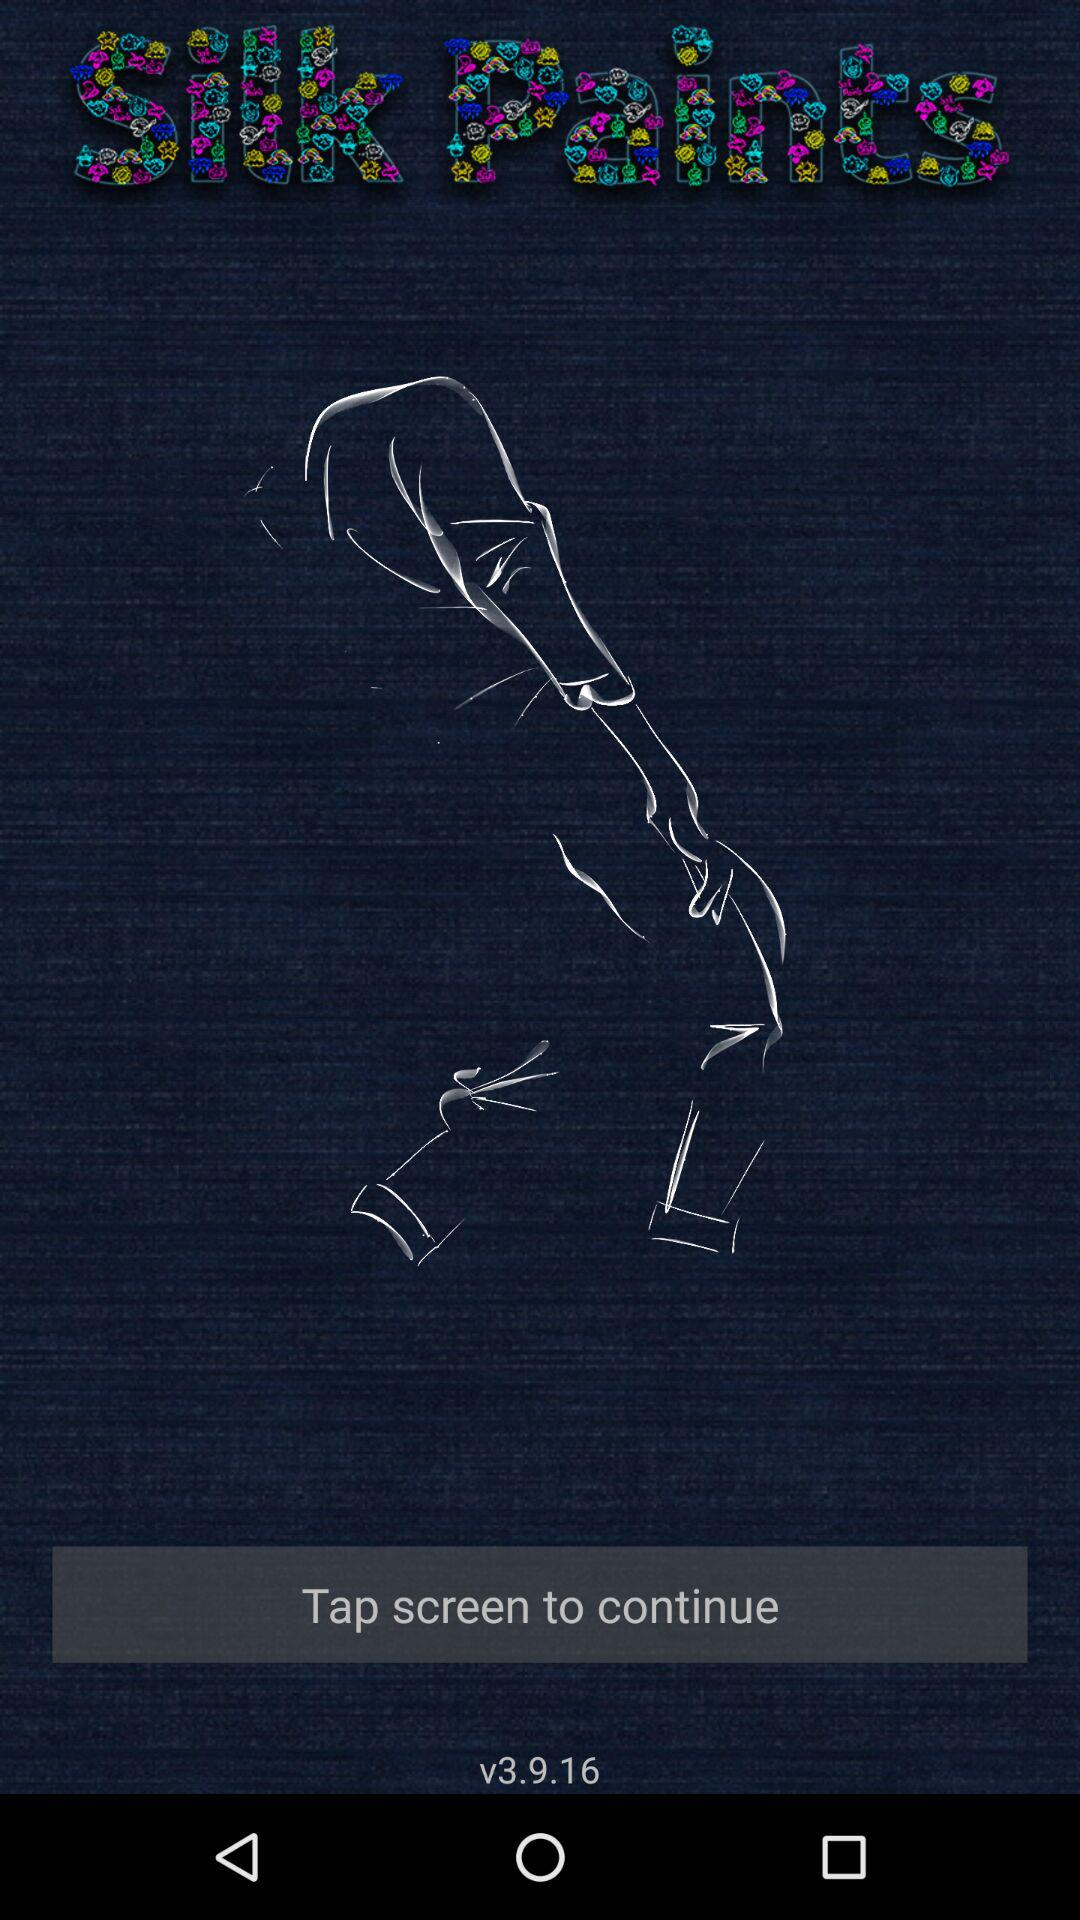What is the name of the application? The name of the application is "Silk Paints". 